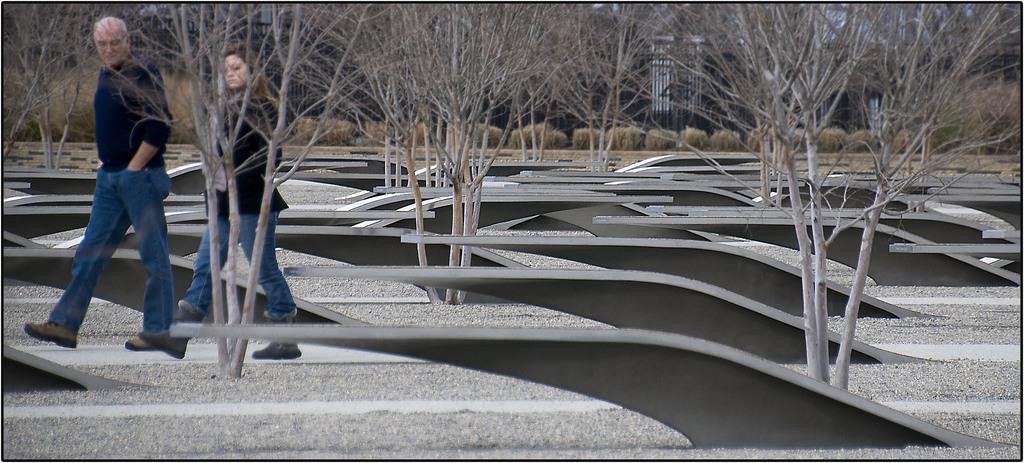In one or two sentences, can you explain what this image depicts? In this image there is a man and a woman walking on the ground. There are objects on the ground. They seem to be benches. In between the objects there are trees. In the background there are buildings and plants. 